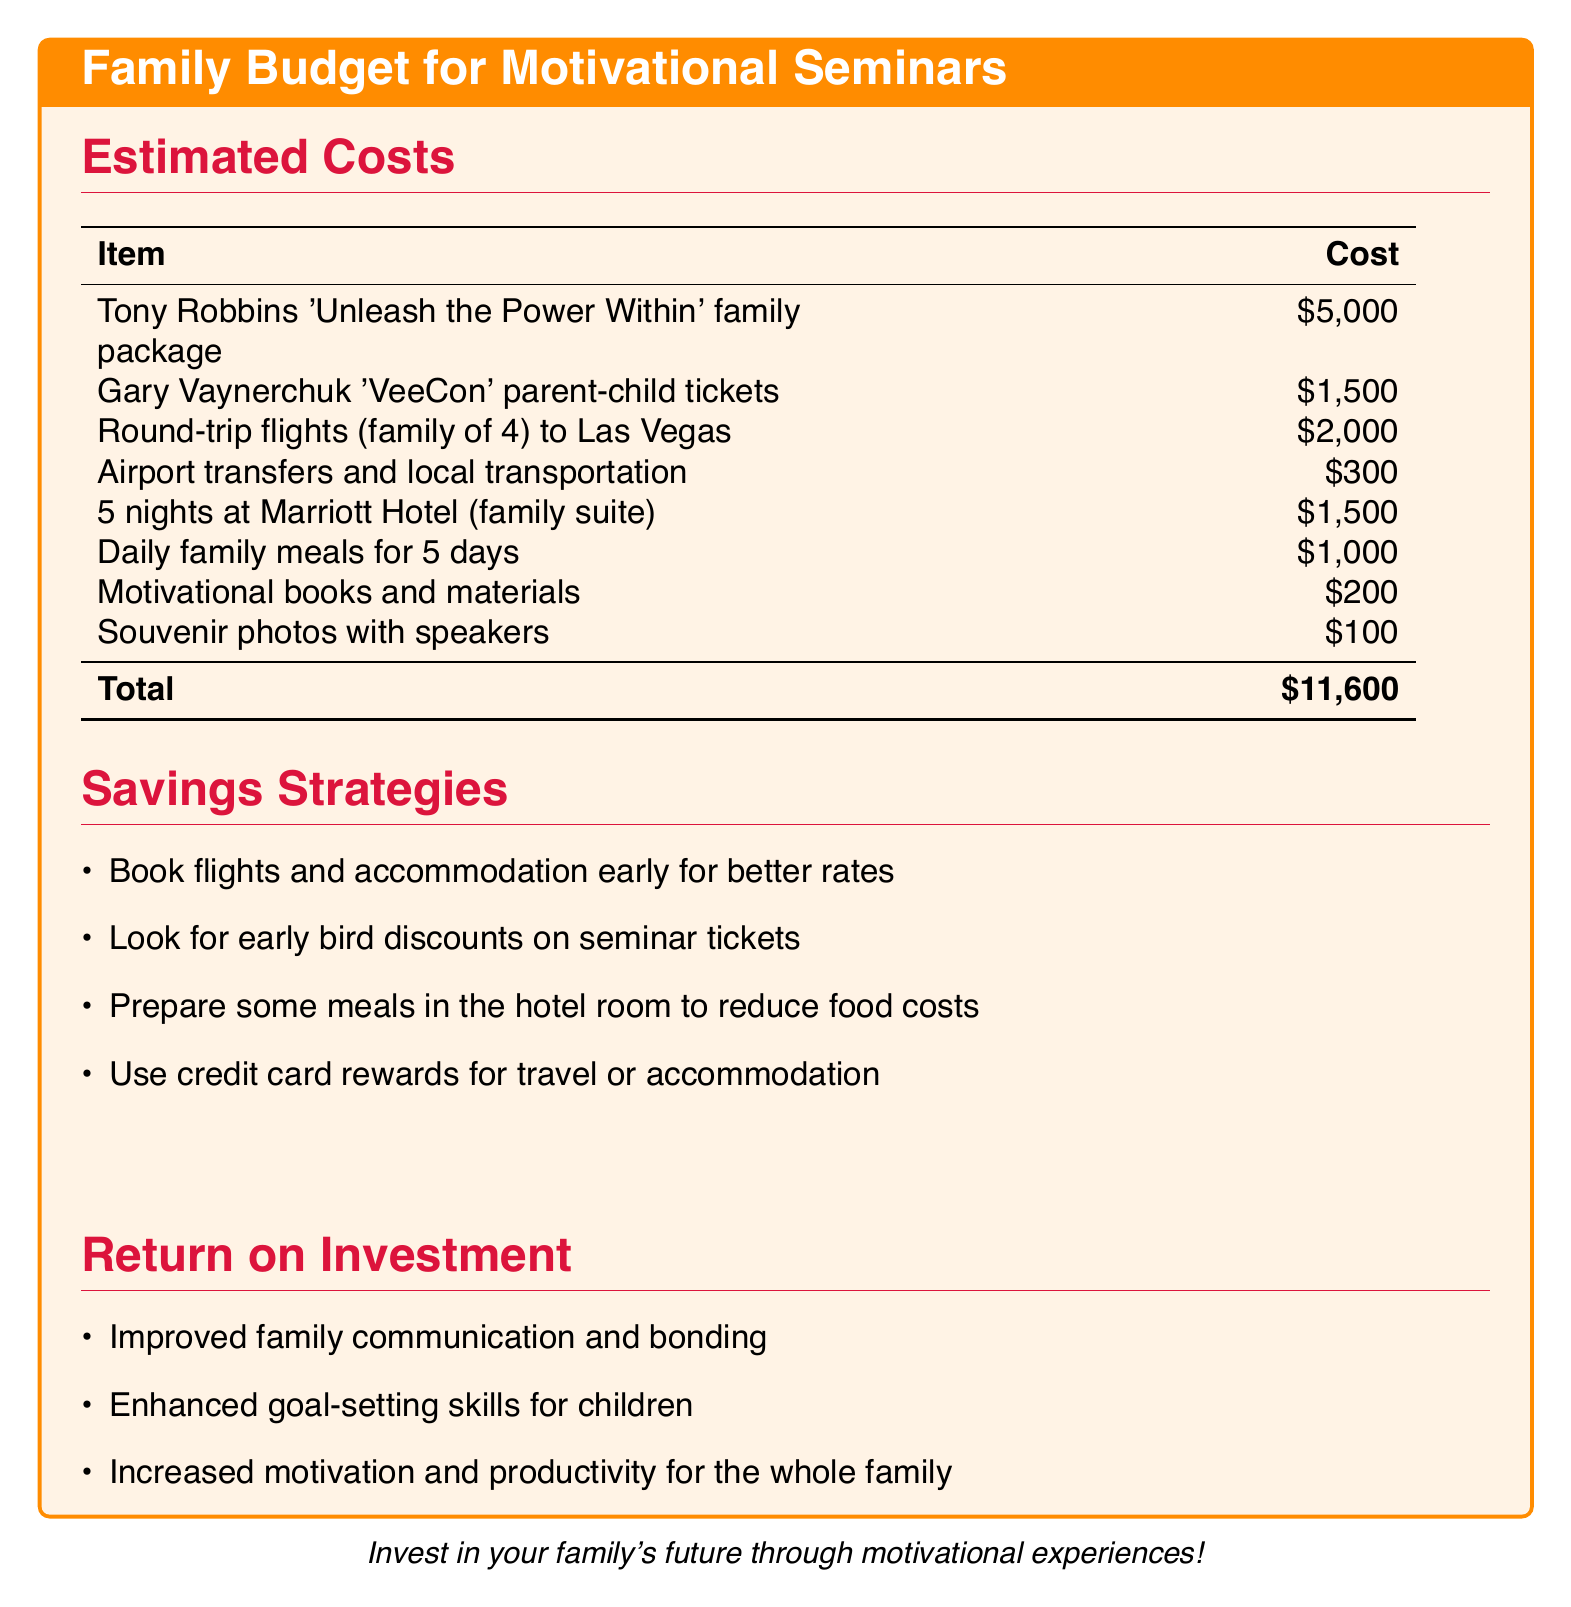What is the total cost of the family budget? The total cost is listed at the bottom of the estimated costs table.
Answer: $11,600 How much do the round-trip flights cost? The cost for the round-trip flights is specified in the estimated costs table.
Answer: $2,000 What is included in the 'Unleash the Power Within' package? The package includes a family seminar experience with Tony Robbins, as indicated in the estimated costs section.
Answer: Tony Robbins 'Unleash the Power Within' family package How many nights is the hotel accommodation for? The number of nights at the Marriott Hotel is mentioned in the estimated costs table.
Answer: 5 nights What savings strategy suggests meal preparation? The savings strategy encouraging meal preparation is listed in the savings strategies section.
Answer: Prepare some meals in the hotel room How much do the souvenir photos with speakers cost? The cost for souvenir photos is stated in the estimated costs table.
Answer: $100 What motivates the family to attend these seminars? The benefits of attending the seminars are outlined in the return on investment section.
Answer: Improved family communication and bonding What type of tickets are mentioned for 'VeeCon'? The type of tickets for the seminar with Gary Vaynerchuk is described in the estimated costs table.
Answer: parent-child tickets 